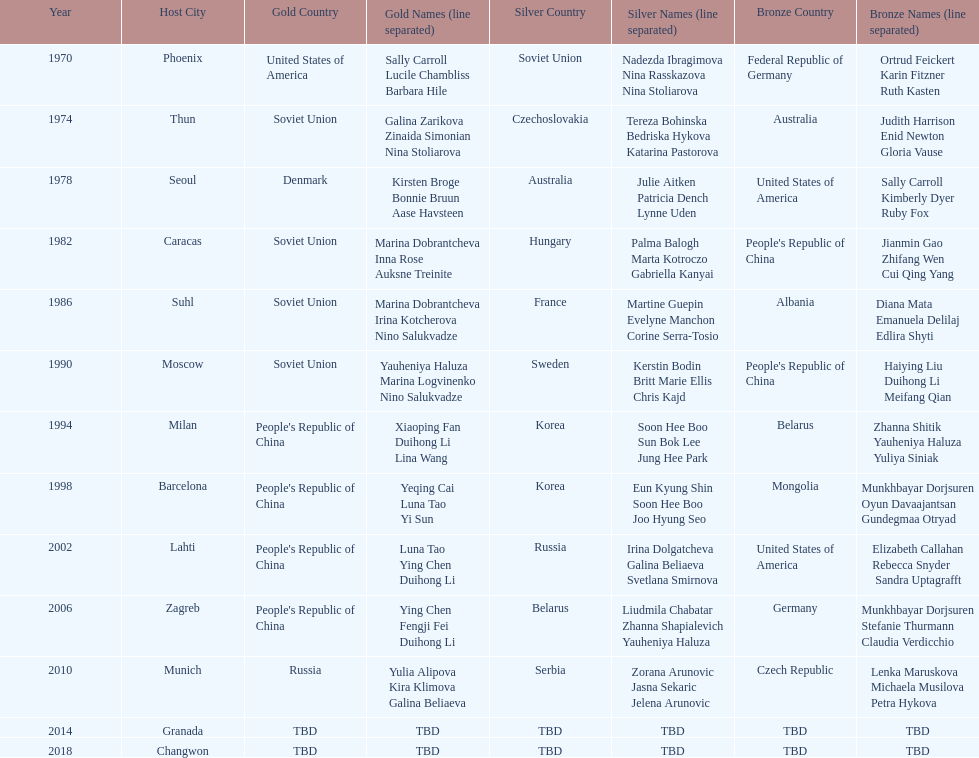How many world championships had the soviet union won first place in in the 25 metre pistol women's world championship? 4. 